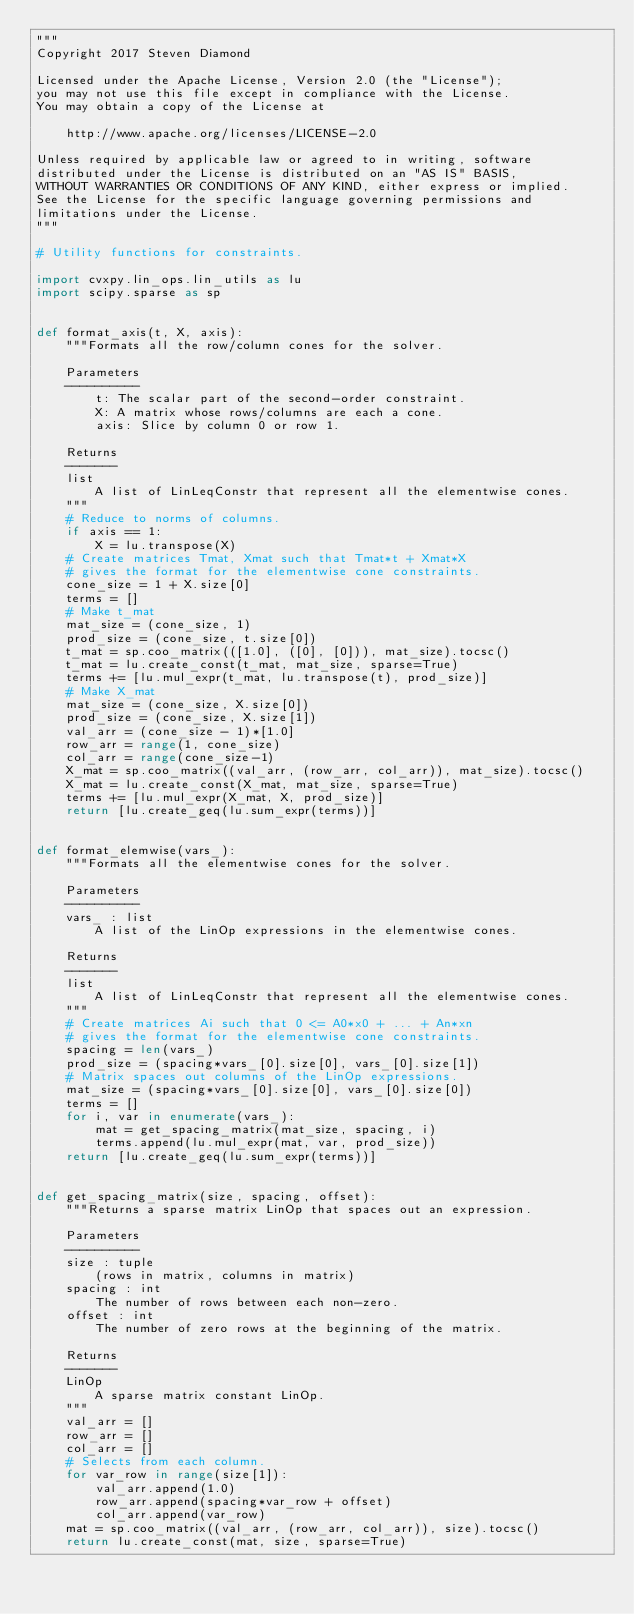<code> <loc_0><loc_0><loc_500><loc_500><_Python_>"""
Copyright 2017 Steven Diamond

Licensed under the Apache License, Version 2.0 (the "License");
you may not use this file except in compliance with the License.
You may obtain a copy of the License at

    http://www.apache.org/licenses/LICENSE-2.0

Unless required by applicable law or agreed to in writing, software
distributed under the License is distributed on an "AS IS" BASIS,
WITHOUT WARRANTIES OR CONDITIONS OF ANY KIND, either express or implied.
See the License for the specific language governing permissions and
limitations under the License.
"""

# Utility functions for constraints.

import cvxpy.lin_ops.lin_utils as lu
import scipy.sparse as sp


def format_axis(t, X, axis):
    """Formats all the row/column cones for the solver.

    Parameters
    ----------
        t: The scalar part of the second-order constraint.
        X: A matrix whose rows/columns are each a cone.
        axis: Slice by column 0 or row 1.

    Returns
    -------
    list
        A list of LinLeqConstr that represent all the elementwise cones.
    """
    # Reduce to norms of columns.
    if axis == 1:
        X = lu.transpose(X)
    # Create matrices Tmat, Xmat such that Tmat*t + Xmat*X
    # gives the format for the elementwise cone constraints.
    cone_size = 1 + X.size[0]
    terms = []
    # Make t_mat
    mat_size = (cone_size, 1)
    prod_size = (cone_size, t.size[0])
    t_mat = sp.coo_matrix(([1.0], ([0], [0])), mat_size).tocsc()
    t_mat = lu.create_const(t_mat, mat_size, sparse=True)
    terms += [lu.mul_expr(t_mat, lu.transpose(t), prod_size)]
    # Make X_mat
    mat_size = (cone_size, X.size[0])
    prod_size = (cone_size, X.size[1])
    val_arr = (cone_size - 1)*[1.0]
    row_arr = range(1, cone_size)
    col_arr = range(cone_size-1)
    X_mat = sp.coo_matrix((val_arr, (row_arr, col_arr)), mat_size).tocsc()
    X_mat = lu.create_const(X_mat, mat_size, sparse=True)
    terms += [lu.mul_expr(X_mat, X, prod_size)]
    return [lu.create_geq(lu.sum_expr(terms))]


def format_elemwise(vars_):
    """Formats all the elementwise cones for the solver.

    Parameters
    ----------
    vars_ : list
        A list of the LinOp expressions in the elementwise cones.

    Returns
    -------
    list
        A list of LinLeqConstr that represent all the elementwise cones.
    """
    # Create matrices Ai such that 0 <= A0*x0 + ... + An*xn
    # gives the format for the elementwise cone constraints.
    spacing = len(vars_)
    prod_size = (spacing*vars_[0].size[0], vars_[0].size[1])
    # Matrix spaces out columns of the LinOp expressions.
    mat_size = (spacing*vars_[0].size[0], vars_[0].size[0])
    terms = []
    for i, var in enumerate(vars_):
        mat = get_spacing_matrix(mat_size, spacing, i)
        terms.append(lu.mul_expr(mat, var, prod_size))
    return [lu.create_geq(lu.sum_expr(terms))]


def get_spacing_matrix(size, spacing, offset):
    """Returns a sparse matrix LinOp that spaces out an expression.

    Parameters
    ----------
    size : tuple
        (rows in matrix, columns in matrix)
    spacing : int
        The number of rows between each non-zero.
    offset : int
        The number of zero rows at the beginning of the matrix.

    Returns
    -------
    LinOp
        A sparse matrix constant LinOp.
    """
    val_arr = []
    row_arr = []
    col_arr = []
    # Selects from each column.
    for var_row in range(size[1]):
        val_arr.append(1.0)
        row_arr.append(spacing*var_row + offset)
        col_arr.append(var_row)
    mat = sp.coo_matrix((val_arr, (row_arr, col_arr)), size).tocsc()
    return lu.create_const(mat, size, sparse=True)
</code> 